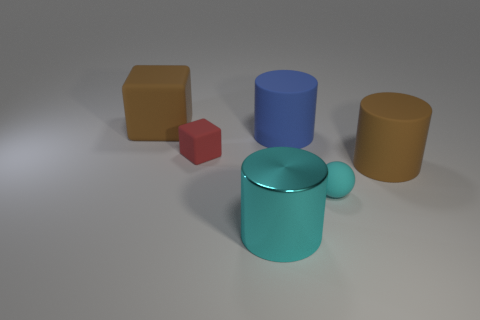There is another thing that is the same color as the metal thing; what is its size?
Provide a short and direct response. Small. What number of things are either red rubber cubes or brown objects behind the blue matte cylinder?
Give a very brief answer. 2. There is a brown thing that is the same material as the big block; what is its size?
Make the answer very short. Large. What shape is the object that is to the right of the small matte object to the right of the big cyan thing?
Make the answer very short. Cylinder. How many yellow objects are tiny shiny objects or metal objects?
Your answer should be compact. 0. Is there a tiny cyan matte ball that is in front of the cube that is right of the brown object that is to the left of the big brown rubber cylinder?
Give a very brief answer. Yes. The tiny matte object that is the same color as the shiny cylinder is what shape?
Ensure brevity in your answer.  Sphere. Are there any other things that have the same material as the large cyan cylinder?
Provide a short and direct response. No. What number of small things are either brown cylinders or cyan shiny cylinders?
Keep it short and to the point. 0. There is a big object in front of the cyan matte object; does it have the same shape as the big blue matte object?
Offer a terse response. Yes. 